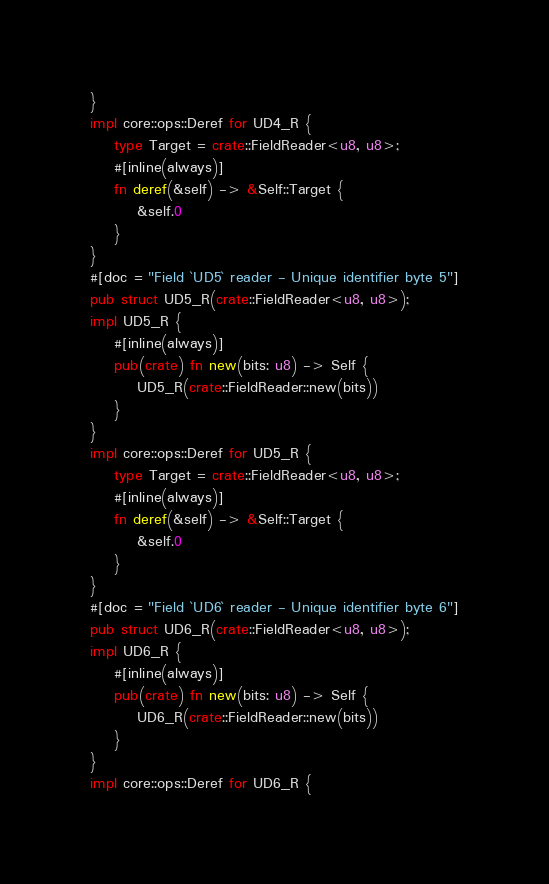Convert code to text. <code><loc_0><loc_0><loc_500><loc_500><_Rust_>}
impl core::ops::Deref for UD4_R {
    type Target = crate::FieldReader<u8, u8>;
    #[inline(always)]
    fn deref(&self) -> &Self::Target {
        &self.0
    }
}
#[doc = "Field `UD5` reader - Unique identifier byte 5"]
pub struct UD5_R(crate::FieldReader<u8, u8>);
impl UD5_R {
    #[inline(always)]
    pub(crate) fn new(bits: u8) -> Self {
        UD5_R(crate::FieldReader::new(bits))
    }
}
impl core::ops::Deref for UD5_R {
    type Target = crate::FieldReader<u8, u8>;
    #[inline(always)]
    fn deref(&self) -> &Self::Target {
        &self.0
    }
}
#[doc = "Field `UD6` reader - Unique identifier byte 6"]
pub struct UD6_R(crate::FieldReader<u8, u8>);
impl UD6_R {
    #[inline(always)]
    pub(crate) fn new(bits: u8) -> Self {
        UD6_R(crate::FieldReader::new(bits))
    }
}
impl core::ops::Deref for UD6_R {</code> 